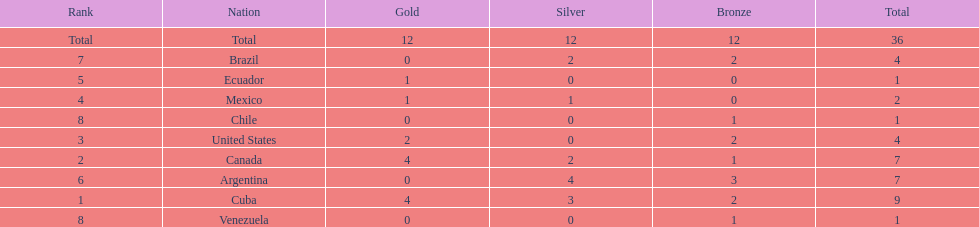What is the overall number of medals argentina secured? 7. 